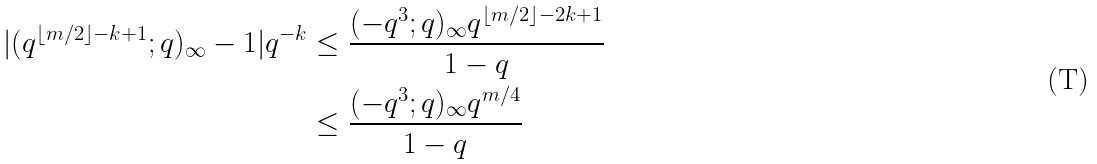Convert formula to latex. <formula><loc_0><loc_0><loc_500><loc_500>| ( q ^ { \left \lfloor m / 2 \right \rfloor - k + 1 } ; q ) _ { \infty } - 1 | q ^ { - k } & \leq \frac { ( - q ^ { 3 } ; q ) _ { \infty } q ^ { \left \lfloor m / 2 \right \rfloor - 2 k + 1 } } { 1 - q } \\ & \leq \frac { ( - q ^ { 3 } ; q ) _ { \infty } q ^ { m / 4 } } { 1 - q }</formula> 